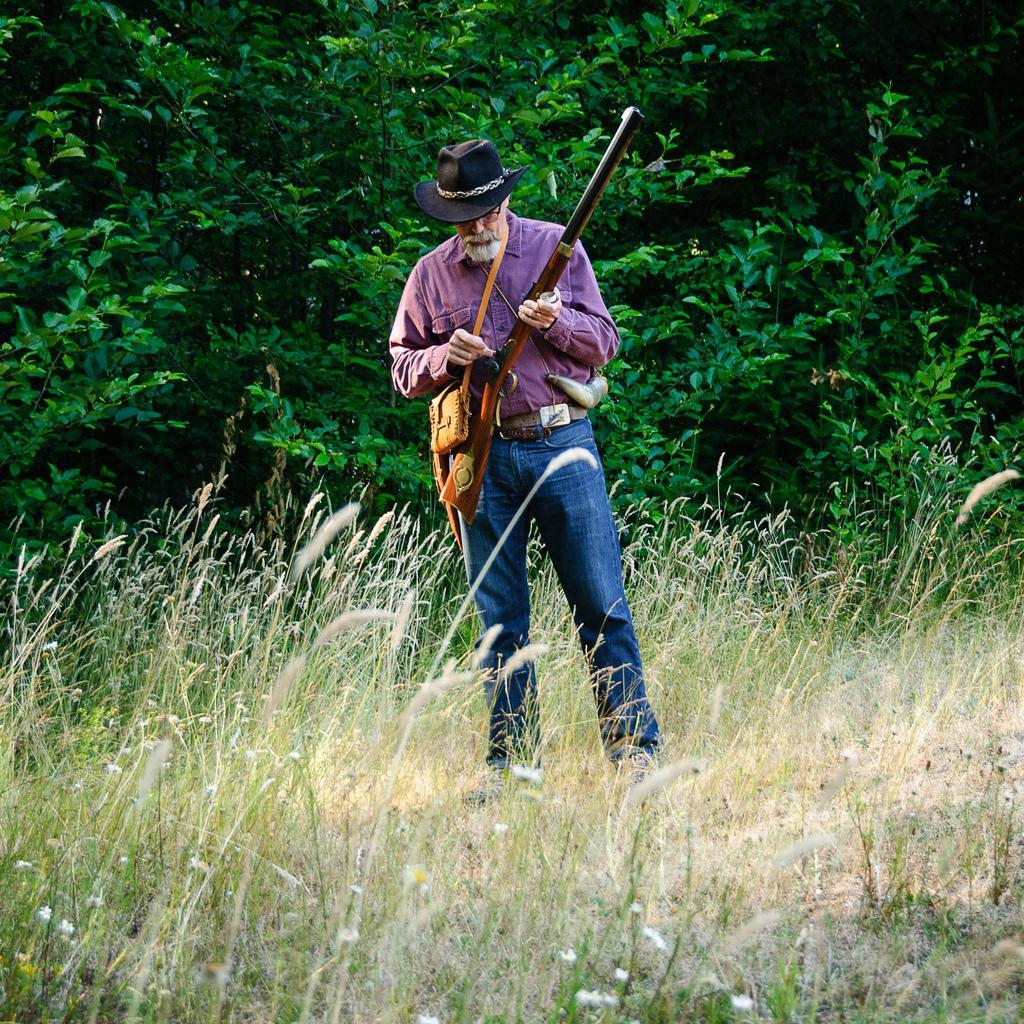Please provide a concise description of this image. This is the picture of a person wearing hat is holding the gun and standing on the floor and behind there are some trees. 